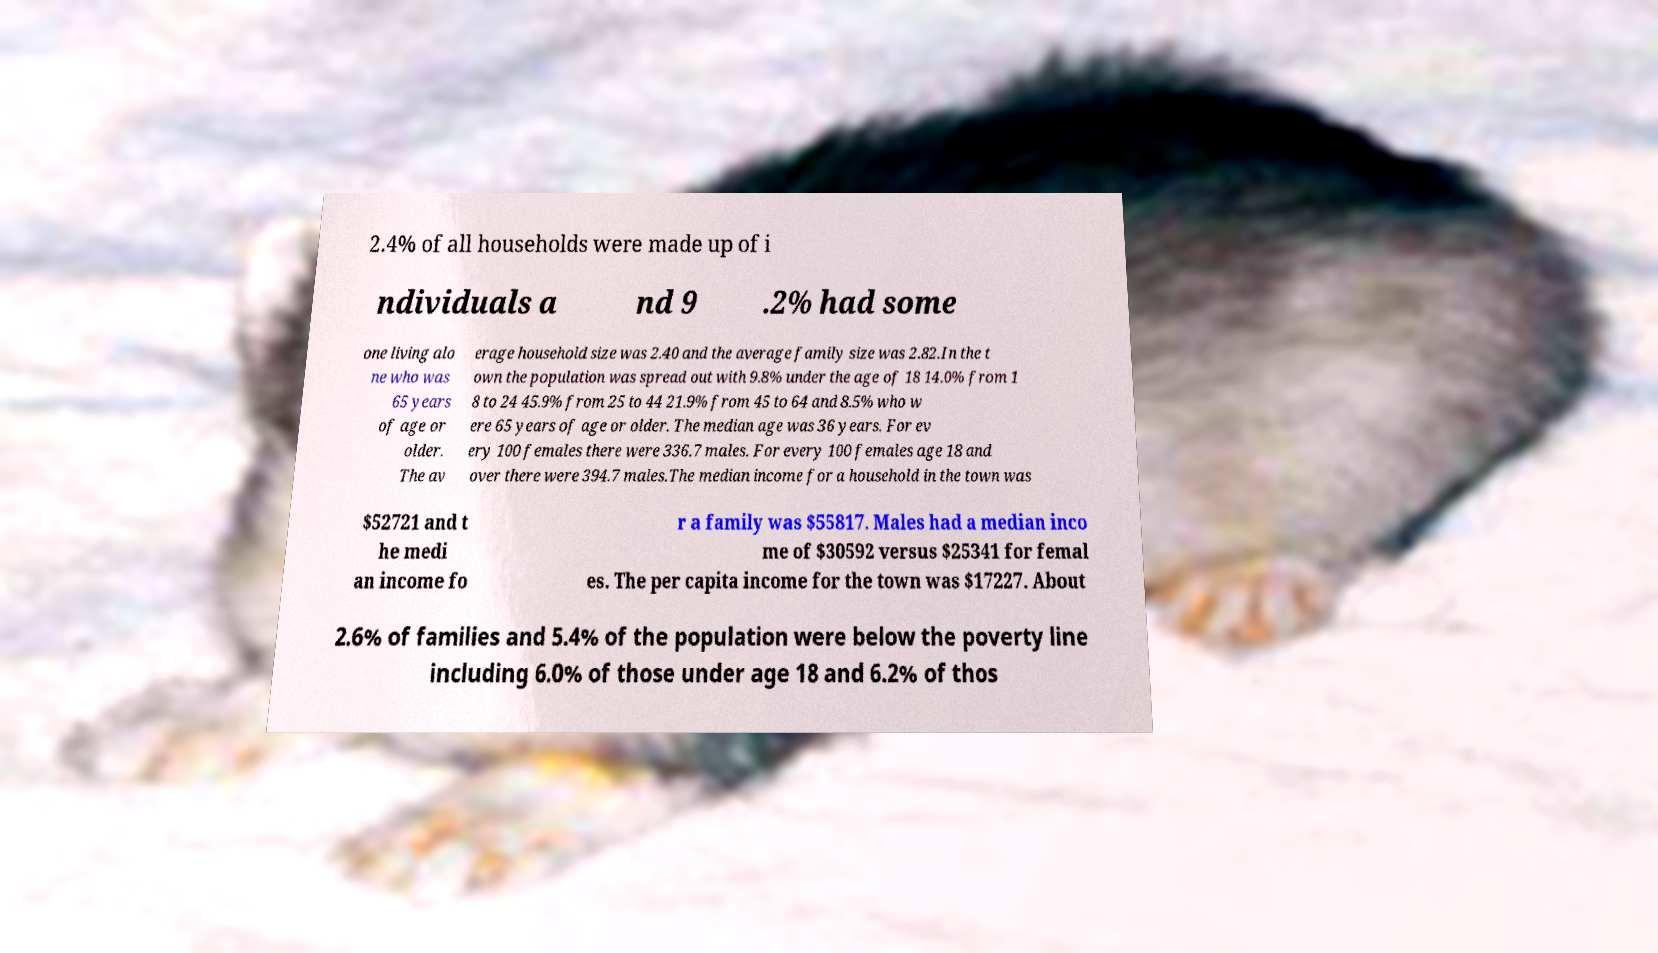Could you extract and type out the text from this image? 2.4% of all households were made up of i ndividuals a nd 9 .2% had some one living alo ne who was 65 years of age or older. The av erage household size was 2.40 and the average family size was 2.82.In the t own the population was spread out with 9.8% under the age of 18 14.0% from 1 8 to 24 45.9% from 25 to 44 21.9% from 45 to 64 and 8.5% who w ere 65 years of age or older. The median age was 36 years. For ev ery 100 females there were 336.7 males. For every 100 females age 18 and over there were 394.7 males.The median income for a household in the town was $52721 and t he medi an income fo r a family was $55817. Males had a median inco me of $30592 versus $25341 for femal es. The per capita income for the town was $17227. About 2.6% of families and 5.4% of the population were below the poverty line including 6.0% of those under age 18 and 6.2% of thos 